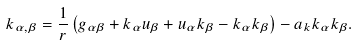<formula> <loc_0><loc_0><loc_500><loc_500>k _ { \alpha , \beta } = \frac { 1 } { r } \left ( g _ { \alpha \beta } + k _ { \alpha } u _ { \beta } + u _ { \alpha } k _ { \beta } - k _ { \alpha } k _ { \beta } \right ) - a _ { k } k _ { \alpha } k _ { \beta } .</formula> 